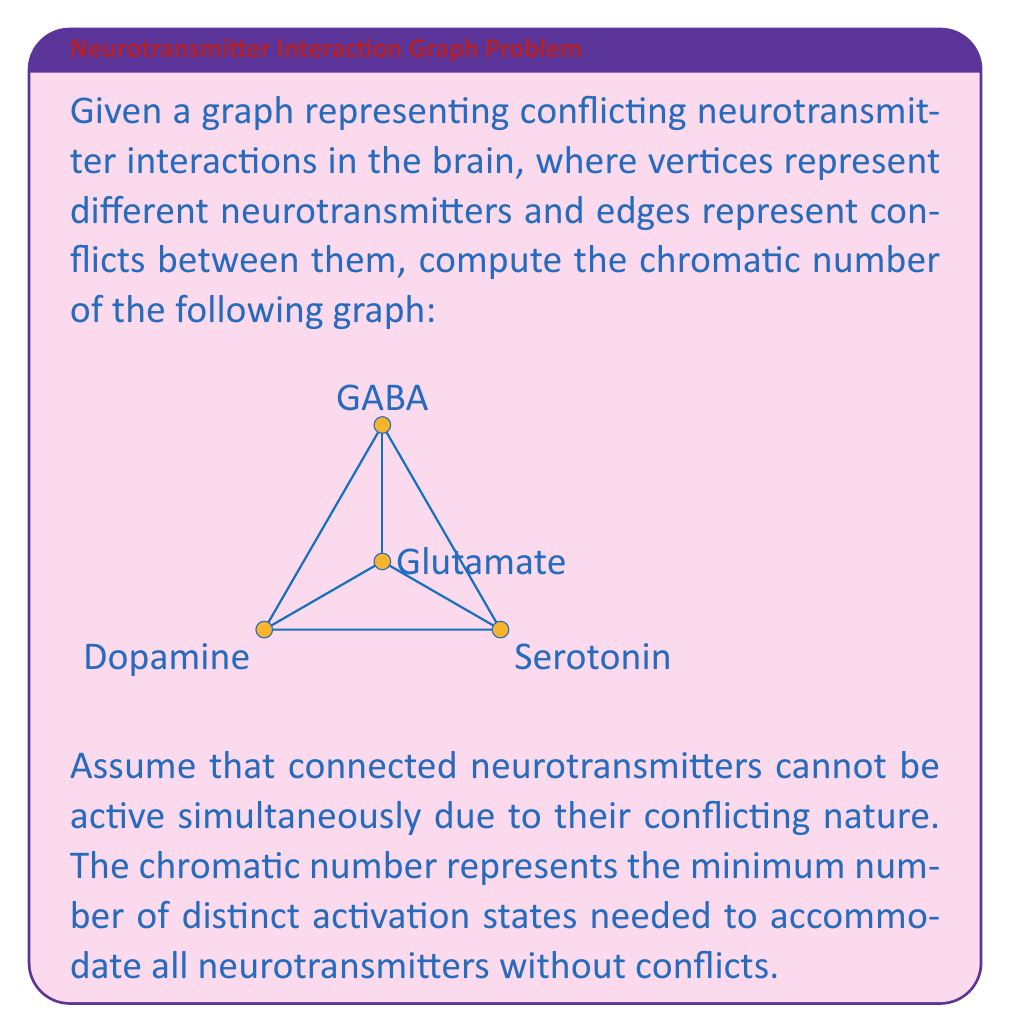Give your solution to this math problem. To solve this problem, we need to understand the concept of graph coloring and chromatic number in the context of neurotransmitter interactions:

1. Graph coloring: Each color represents a distinct activation state for neurotransmitters.
2. Chromatic number: The minimum number of colors needed to color all vertices such that no two adjacent vertices have the same color.

Let's approach this step-by-step:

1. Identify the vertices:
   - A: Dopamine
   - B: Serotonin
   - C: GABA
   - D: Glutamate

2. Analyze the graph structure:
   - The graph forms a wheel with 4 vertices.
   - Vertex D (Glutamate) is connected to all other vertices.

3. Start coloring:
   - Assign color 1 to vertex A (Dopamine).
   - Vertex B (Serotonin) is adjacent to A, so it needs a different color. Assign color 2.
   - Vertex C (GABA) is adjacent to both A and B, so it needs a third color. Assign color 3.
   - Vertex D (Glutamate) is adjacent to all other vertices, so it needs a fourth color. Assign color 4.

4. Verify:
   - No two adjacent vertices have the same color.
   - We used 4 colors in total.

5. Optimality:
   - Since vertex D is connected to all other vertices, it must have a unique color.
   - The remaining three vertices form a triangle, requiring three distinct colors.
   - Therefore, 4 is the minimum number of colors needed.

The chromatic number χ(G) is thus 4, meaning we need at least 4 distinct activation states to accommodate all neurotransmitters without conflicts.

This result suggests that in this simplified model, the brain requires at least 4 different activation states to manage these neurotransmitter interactions without conflicts, which could have implications for understanding neurotransmitter dynamics in neurodegenerative disorders.
Answer: The chromatic number of the given graph is χ(G) = 4. 